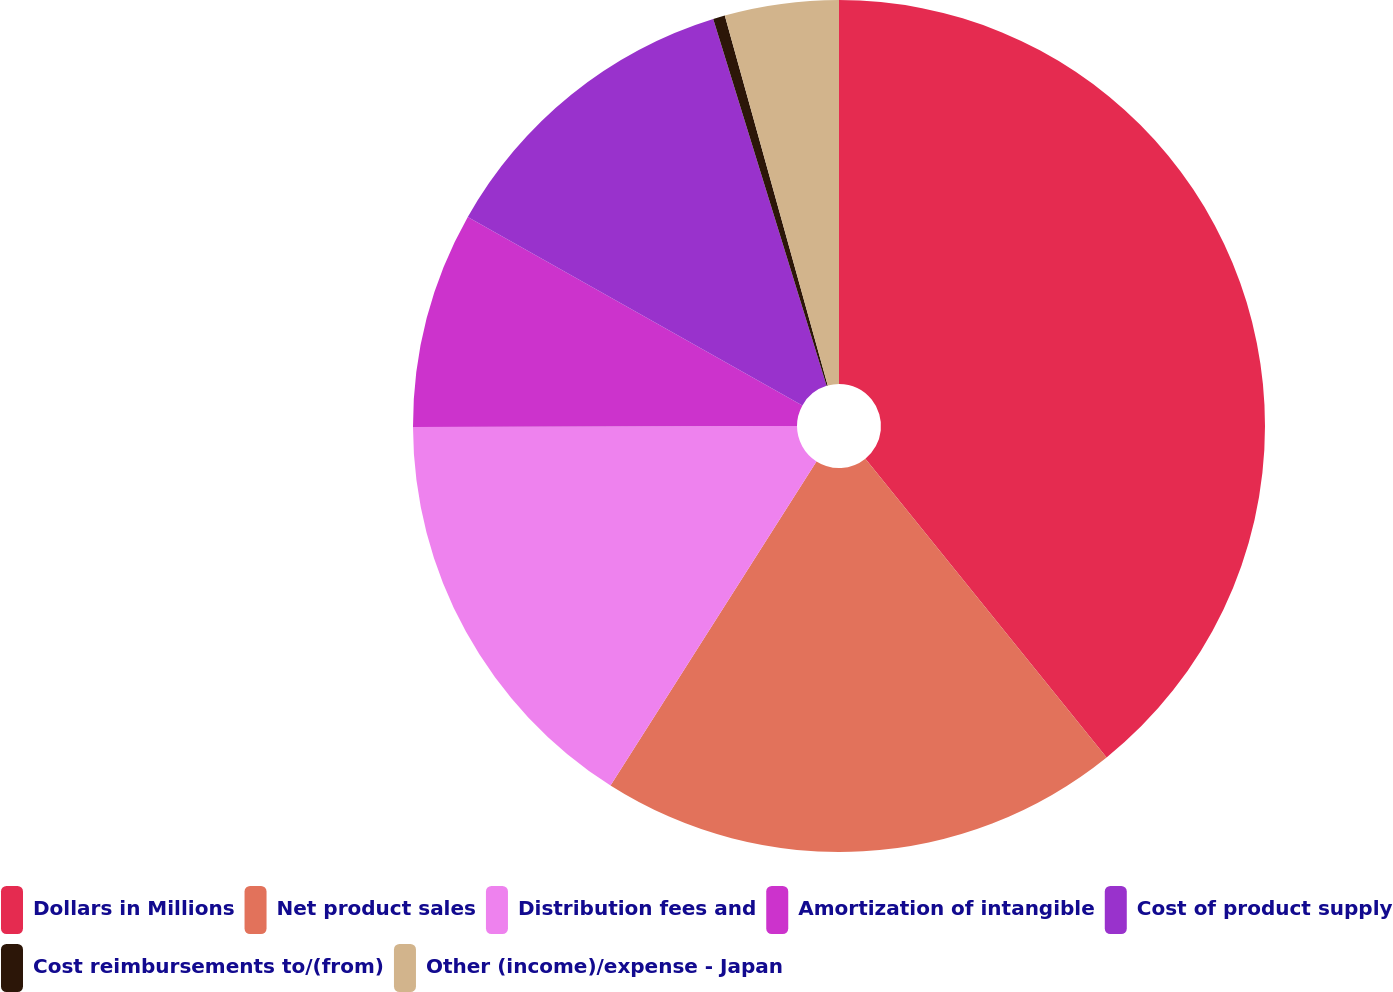<chart> <loc_0><loc_0><loc_500><loc_500><pie_chart><fcel>Dollars in Millions<fcel>Net product sales<fcel>Distribution fees and<fcel>Amortization of intangible<fcel>Cost of product supply<fcel>Cost reimbursements to/(from)<fcel>Other (income)/expense - Japan<nl><fcel>39.19%<fcel>19.82%<fcel>15.95%<fcel>8.2%<fcel>12.07%<fcel>0.45%<fcel>4.32%<nl></chart> 